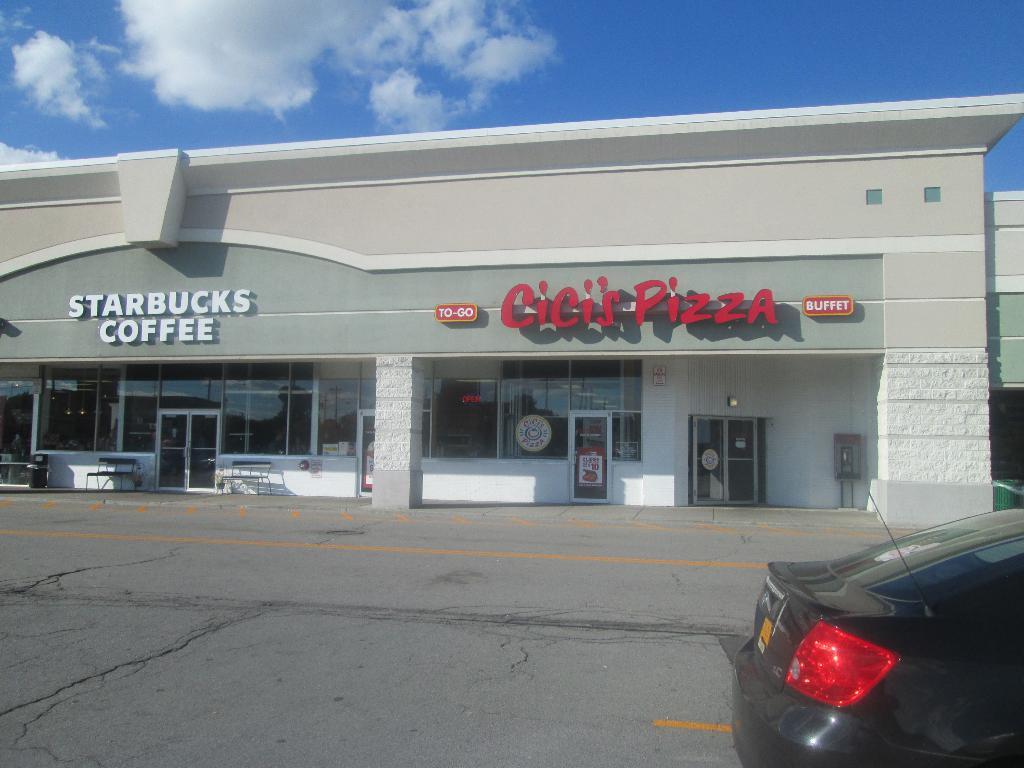How would you summarize this image in a sentence or two? In this picture I can observe a building. There is some text on the building. In front of the building there is a road. On the right side I can observe a black color car on the road. In the background there are some clouds in the sky. 